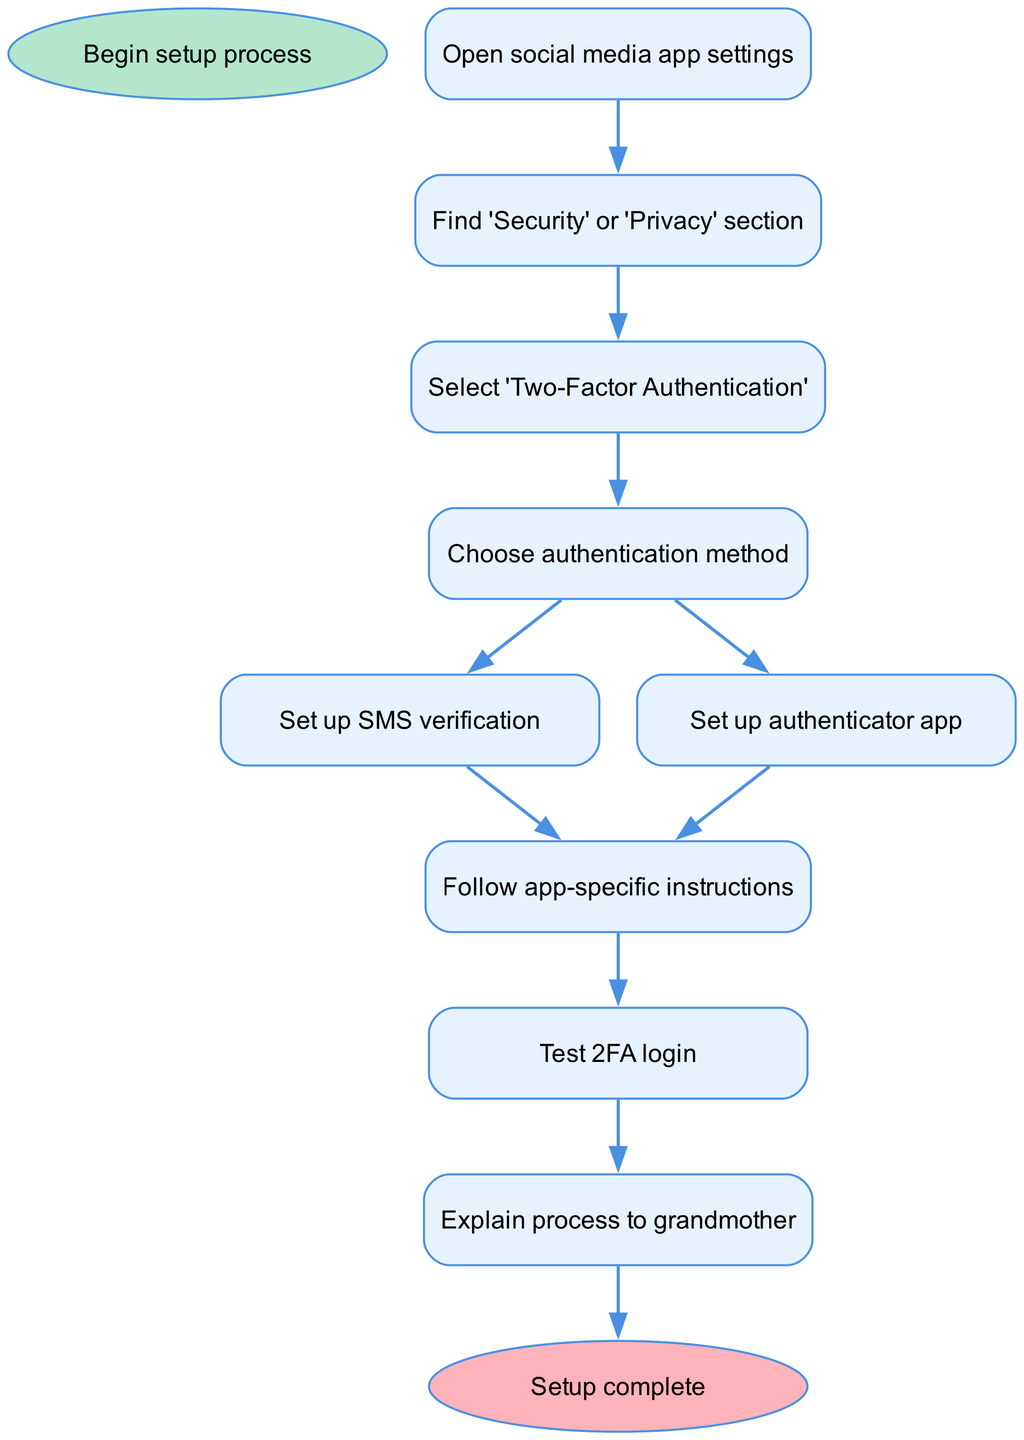What's the first step in the flowchart? The diagram indicates that the first step is to "Open social media app settings." This is the initial action that starts the process of setting up two-factor authentication.
Answer: Open social media app settings How many steps are there in the flowchart? Upon reviewing the steps listed in the flowchart, there are a total of 8 steps leading up to the completion of the two-factor authentication setup process.
Answer: 8 What are the two options for the authentication method? The options for choosing an authentication method within the flowchart are "Set up SMS verification" and "Set up authenticator app." These are the two methods indicated for the user.
Answer: Set up SMS verification, Set up authenticator app What is the last step before completing the setup? The last step indicated before reaching the end of the flowchart is "Explain process to grandmother." This step suggests that after testing the two-factor authentication, the user should explain how it works to someone else.
Answer: Explain process to grandmother What follows the selection of the authentication method? After selecting the authentication method, the next step is to "Follow app-specific instructions." This means that after choosing either SMS verification or an authenticator app, users have to follow the specific instructions relevant to their chosen method.
Answer: Follow app-specific instructions How does one proceed after testing the 2FA login? After testing the 2FA login, the next action is to "Explain process to grandmother." This indicates that once the user has confirmed that the two-factor authentication works, they should discuss it with their grandmother as part of the learning process.
Answer: Explain process to grandmother Which step directly leads to testing the 2FA login? The step that directly leads to testing the 2FA login is "Follow app-specific instructions." This instruction enables the user to set up their chosen two-factor authentication method, thereby allowing them to test it afterward.
Answer: Follow app-specific instructions Is there a branching point in the flowchart? Yes, there is a branching point after the step "Choose authentication method," where the user can either "Set up SMS verification" or "Set up authenticator app." This represents a choice that leads to different paths in the diagram.
Answer: Yes 